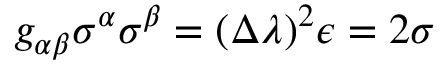<formula> <loc_0><loc_0><loc_500><loc_500>g _ { \alpha \beta } \sigma ^ { \alpha } \sigma ^ { \beta } = ( \Delta \lambda ) ^ { 2 } \epsilon = 2 \sigma</formula> 